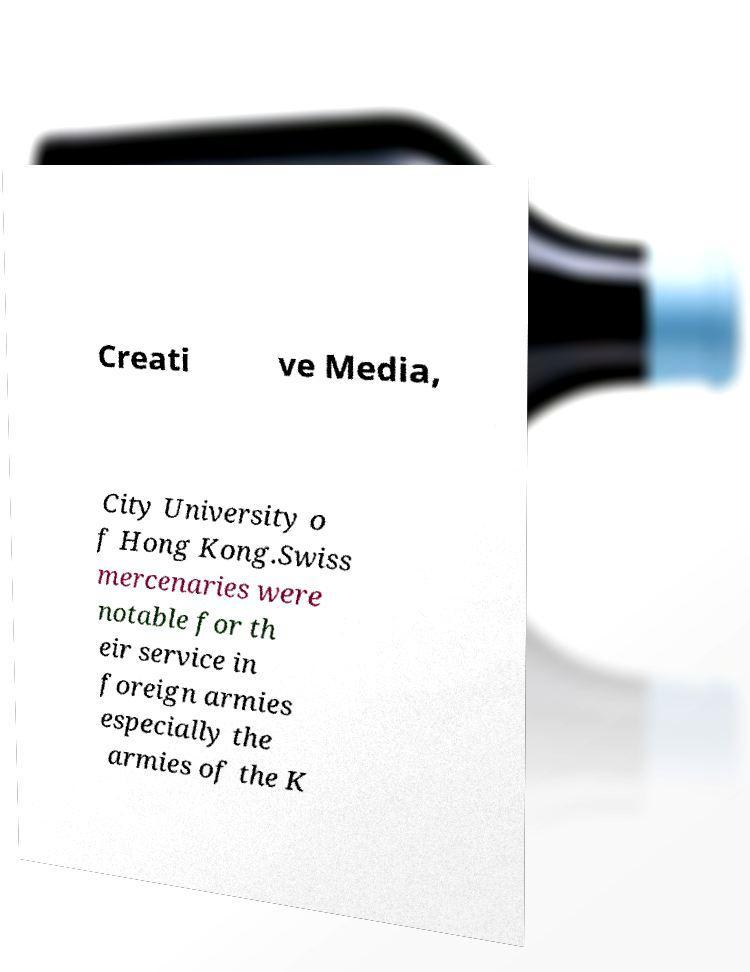I need the written content from this picture converted into text. Can you do that? Creati ve Media, City University o f Hong Kong.Swiss mercenaries were notable for th eir service in foreign armies especially the armies of the K 